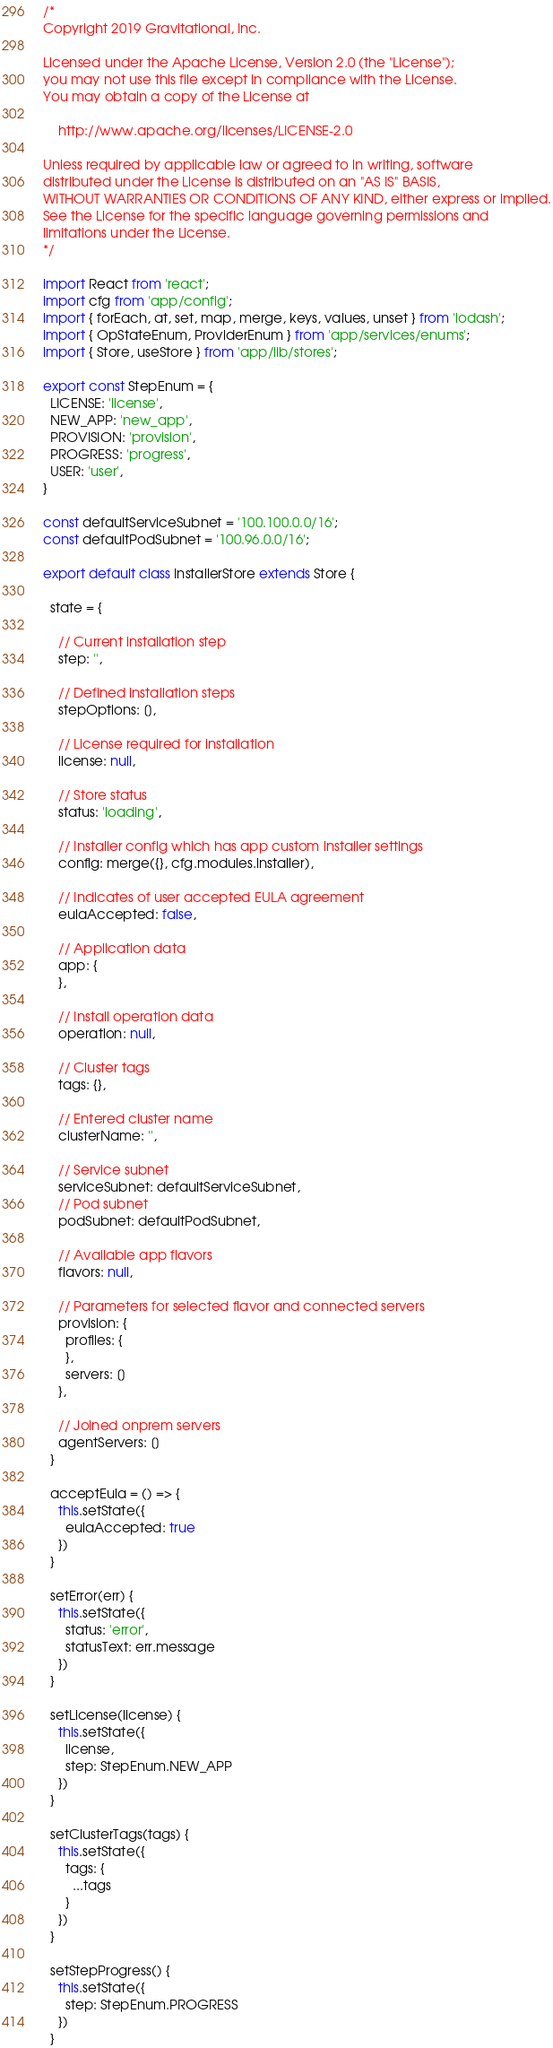<code> <loc_0><loc_0><loc_500><loc_500><_JavaScript_>/*
Copyright 2019 Gravitational, Inc.

Licensed under the Apache License, Version 2.0 (the "License");
you may not use this file except in compliance with the License.
You may obtain a copy of the License at

    http://www.apache.org/licenses/LICENSE-2.0

Unless required by applicable law or agreed to in writing, software
distributed under the License is distributed on an "AS IS" BASIS,
WITHOUT WARRANTIES OR CONDITIONS OF ANY KIND, either express or implied.
See the License for the specific language governing permissions and
limitations under the License.
*/

import React from 'react';
import cfg from 'app/config';
import { forEach, at, set, map, merge, keys, values, unset } from 'lodash';
import { OpStateEnum, ProviderEnum } from 'app/services/enums';
import { Store, useStore } from 'app/lib/stores';

export const StepEnum = {
  LICENSE: 'license',
  NEW_APP: 'new_app',
  PROVISION: 'provision',
  PROGRESS: 'progress',
  USER: 'user',
}

const defaultServiceSubnet = '100.100.0.0/16';
const defaultPodSubnet = '100.96.0.0/16';

export default class InstallerStore extends Store {

  state = {

    // Current installation step
    step: '',

    // Defined installation steps
    stepOptions: [],

    // License required for installation
    license: null,

    // Store status
    status: 'loading',

    // Installer config which has app custom installer settings
    config: merge({}, cfg.modules.installer),

    // Indicates of user accepted EULA agreement
    eulaAccepted: false,

    // Application data
    app: {
    },

    // Install operation data
    operation: null,

    // Cluster tags
    tags: {},

    // Entered cluster name
    clusterName: '',

    // Service subnet
    serviceSubnet: defaultServiceSubnet,
    // Pod subnet
    podSubnet: defaultPodSubnet,

    // Available app flavors
    flavors: null,

    // Parameters for selected flavor and connected servers
    provision: {
      profiles: {
      },
      servers: []
    },

    // Joined onprem servers
    agentServers: []
  }

  acceptEula = () => {
    this.setState({
      eulaAccepted: true
    })
  }

  setError(err) {
    this.setState({
      status: 'error',
      statusText: err.message
    })
  }

  setLicense(license) {
    this.setState({
      license,
      step: StepEnum.NEW_APP
    })
  }

  setClusterTags(tags) {
    this.setState({
      tags: {
        ...tags
      }
    })
  }

  setStepProgress() {
    this.setState({
      step: StepEnum.PROGRESS
    })
  }
</code> 